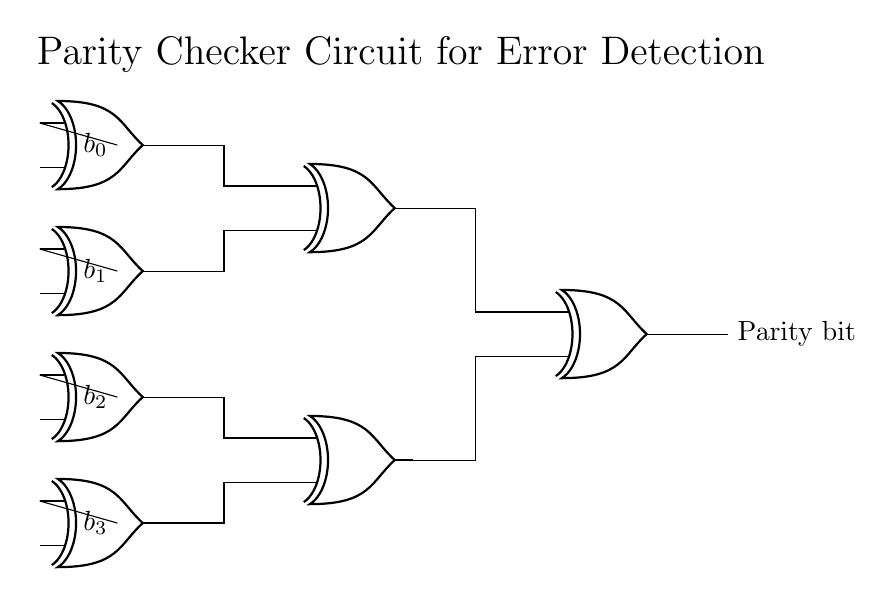What logic gate is predominantly used in this circuit? The circuit primarily uses XOR gates, which are essential for parity checking as they output true only when an odd number of inputs are true.
Answer: XOR gates How many input bits does the circuit take? The circuit has four input bits (b0, b1, b2, and b3), as shown on the left side of the diagram.
Answer: Four What is the output of the circuit labeled as? The output of the circuit is labeled as "Parity bit," indicating that it serves to check the parity of the input bits.
Answer: Parity bit How many XOR gates are used in total? There are seven XOR gates in the circuit: four for the initial inputs, two for intermediate calculations, and one final gate for the output.
Answer: Seven Which XOR gate combines the outputs of the first set of XOR gates? The XOR gate labeled as 5 combines the outputs of the first set of XOR gates (1 and 2). It processes the intermediate results before sending them to the final gate.
Answer: XOR gate 5 What function does the final XOR gate serve in the circuit? The final XOR gate calculates the overall parity by combining the outputs of the intermediate XOR gates, determining if the total number of 1's is even or odd.
Answer: Determines overall parity 